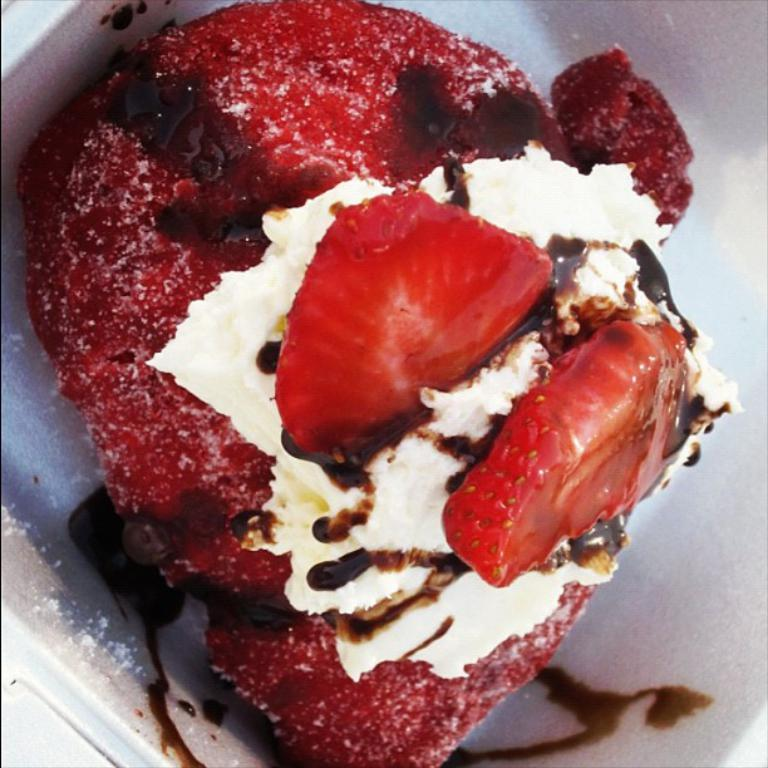What is the main subject of the image? There is a food item in the image. How is the food item presented in the image? The food item is on a plate. Where is the plate located in the image? The plate is located in the center of the image. What type of juice can be seen flowing from the board in the image? There is no board or juice present in the image. 